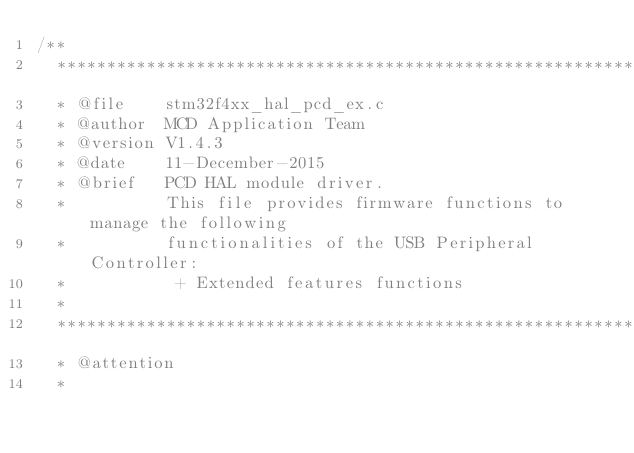Convert code to text. <code><loc_0><loc_0><loc_500><loc_500><_C_>/**
  ******************************************************************************
  * @file    stm32f4xx_hal_pcd_ex.c
  * @author  MCD Application Team
  * @version V1.4.3
  * @date    11-December-2015
  * @brief   PCD HAL module driver.
  *          This file provides firmware functions to manage the following 
  *          functionalities of the USB Peripheral Controller:
  *           + Extended features functions
  *
  ******************************************************************************
  * @attention
  *</code> 